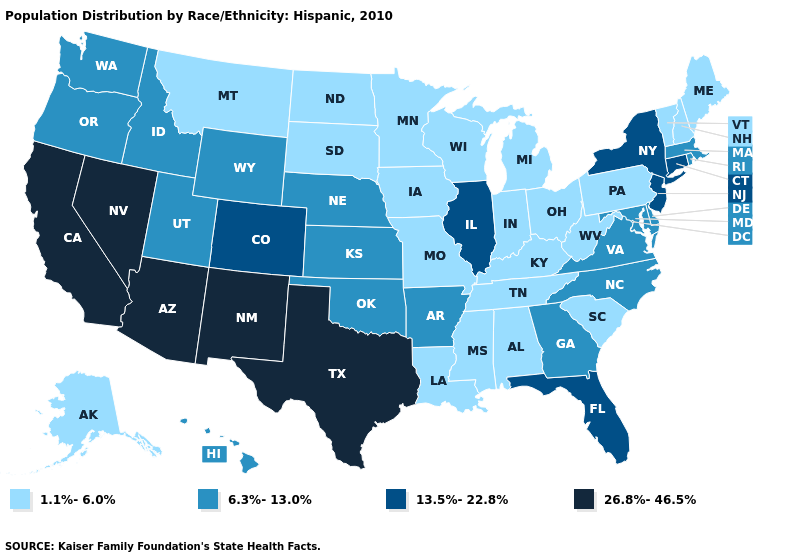What is the highest value in the USA?
Answer briefly. 26.8%-46.5%. Name the states that have a value in the range 13.5%-22.8%?
Concise answer only. Colorado, Connecticut, Florida, Illinois, New Jersey, New York. Does Washington have a lower value than South Dakota?
Concise answer only. No. What is the highest value in the USA?
Short answer required. 26.8%-46.5%. Which states have the lowest value in the MidWest?
Keep it brief. Indiana, Iowa, Michigan, Minnesota, Missouri, North Dakota, Ohio, South Dakota, Wisconsin. Name the states that have a value in the range 13.5%-22.8%?
Keep it brief. Colorado, Connecticut, Florida, Illinois, New Jersey, New York. Name the states that have a value in the range 6.3%-13.0%?
Quick response, please. Arkansas, Delaware, Georgia, Hawaii, Idaho, Kansas, Maryland, Massachusetts, Nebraska, North Carolina, Oklahoma, Oregon, Rhode Island, Utah, Virginia, Washington, Wyoming. What is the value of South Carolina?
Give a very brief answer. 1.1%-6.0%. Name the states that have a value in the range 13.5%-22.8%?
Answer briefly. Colorado, Connecticut, Florida, Illinois, New Jersey, New York. Among the states that border Idaho , which have the lowest value?
Short answer required. Montana. Does Tennessee have the same value as Georgia?
Quick response, please. No. Among the states that border Utah , which have the lowest value?
Short answer required. Idaho, Wyoming. What is the lowest value in the USA?
Short answer required. 1.1%-6.0%. What is the value of Virginia?
Be succinct. 6.3%-13.0%. Does North Dakota have a lower value than Oklahoma?
Give a very brief answer. Yes. 